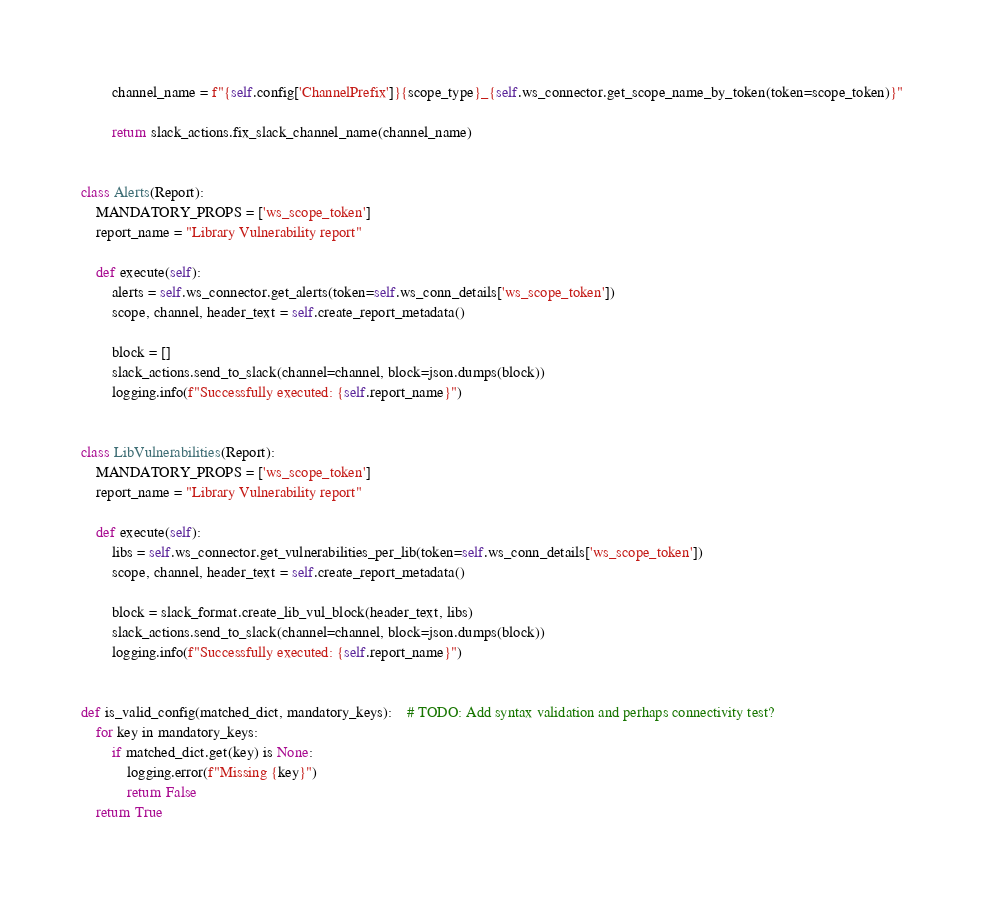<code> <loc_0><loc_0><loc_500><loc_500><_Python_>        channel_name = f"{self.config['ChannelPrefix']}{scope_type}_{self.ws_connector.get_scope_name_by_token(token=scope_token)}"

        return slack_actions.fix_slack_channel_name(channel_name)


class Alerts(Report):
    MANDATORY_PROPS = ['ws_scope_token']
    report_name = "Library Vulnerability report"

    def execute(self):
        alerts = self.ws_connector.get_alerts(token=self.ws_conn_details['ws_scope_token'])
        scope, channel, header_text = self.create_report_metadata()

        block = []
        slack_actions.send_to_slack(channel=channel, block=json.dumps(block))
        logging.info(f"Successfully executed: {self.report_name}")


class LibVulnerabilities(Report):
    MANDATORY_PROPS = ['ws_scope_token']
    report_name = "Library Vulnerability report"

    def execute(self):
        libs = self.ws_connector.get_vulnerabilities_per_lib(token=self.ws_conn_details['ws_scope_token'])
        scope, channel, header_text = self.create_report_metadata()

        block = slack_format.create_lib_vul_block(header_text, libs)
        slack_actions.send_to_slack(channel=channel, block=json.dumps(block))
        logging.info(f"Successfully executed: {self.report_name}")


def is_valid_config(matched_dict, mandatory_keys):    # TODO: Add syntax validation and perhaps connectivity test?
    for key in mandatory_keys:
        if matched_dict.get(key) is None:
            logging.error(f"Missing {key}")
            return False
    return True
</code> 